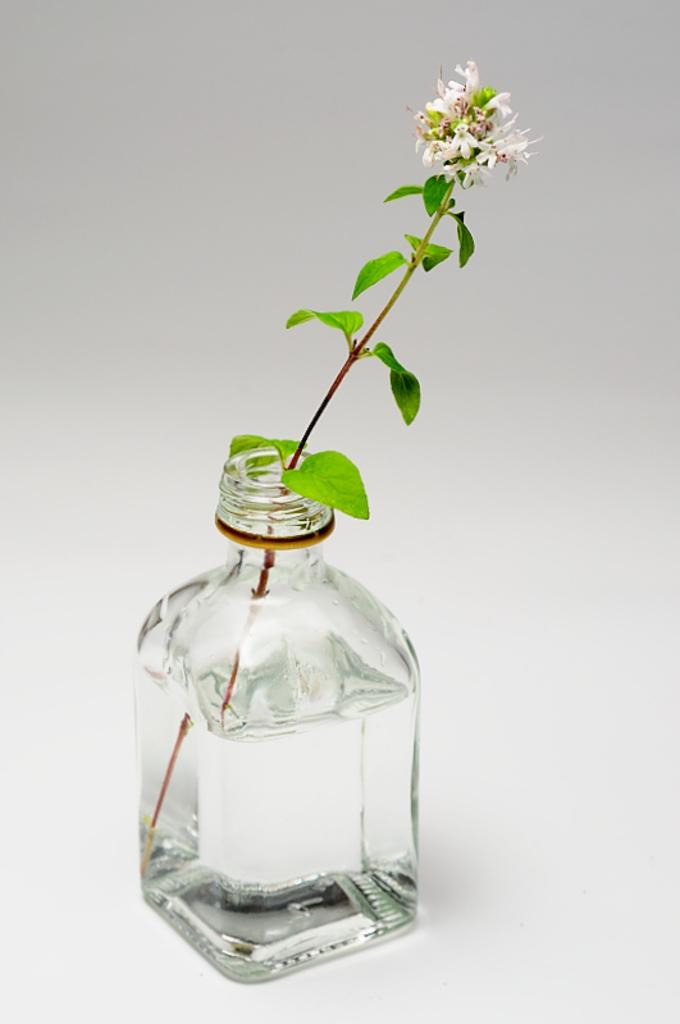What object can be seen in the image that typically contains a liquid? There is a bottle in the image that typically contains a liquid. What living organism is present in the image? There is a plant in the image. Can you describe the ghost that is sitting on the chairs in the image? There is no ghost or chairs present in the image; it only features a bottle and a plant. 